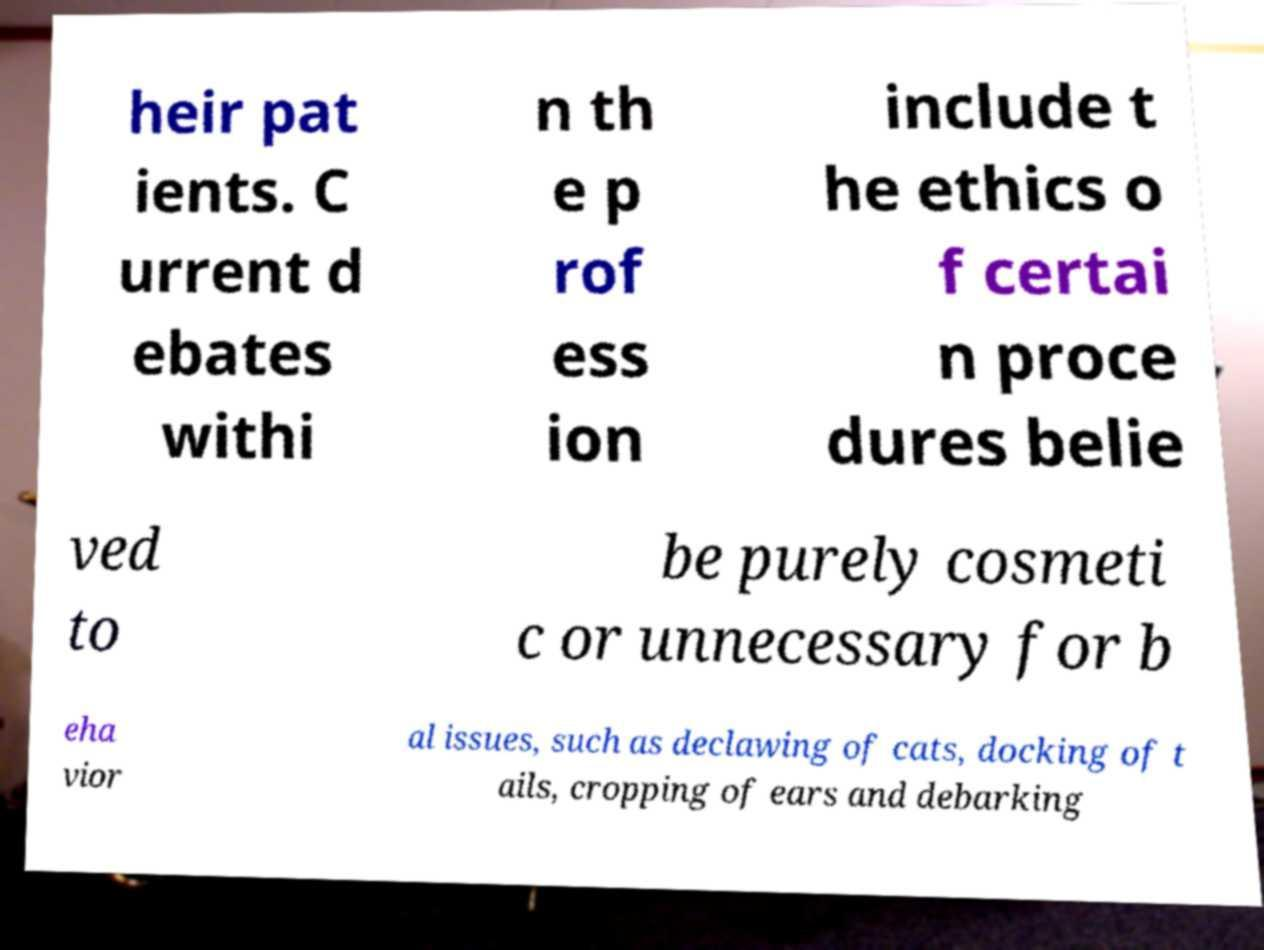Could you extract and type out the text from this image? heir pat ients. C urrent d ebates withi n th e p rof ess ion include t he ethics o f certai n proce dures belie ved to be purely cosmeti c or unnecessary for b eha vior al issues, such as declawing of cats, docking of t ails, cropping of ears and debarking 